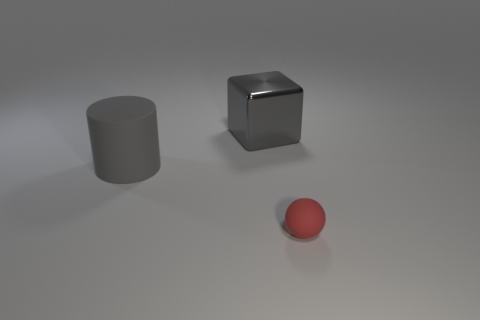What material is the big thing that is on the right side of the large object in front of the gray cube made of?
Offer a terse response. Metal. What shape is the gray thing left of the thing that is behind the matte thing behind the tiny sphere?
Your response must be concise. Cylinder. What number of cylinders are there?
Make the answer very short. 1. What is the shape of the big gray object in front of the big gray block?
Your response must be concise. Cylinder. There is a matte thing behind the matte thing to the right of the matte thing that is behind the tiny sphere; what is its color?
Provide a succinct answer. Gray. What shape is the other big object that is the same material as the red thing?
Make the answer very short. Cylinder. Are there fewer big red matte cylinders than big gray metal objects?
Provide a succinct answer. Yes. Do the small red ball and the big gray cube have the same material?
Ensure brevity in your answer.  No. What number of other objects are the same color as the ball?
Your answer should be very brief. 0. Is the number of tiny red rubber objects greater than the number of big cyan matte objects?
Offer a very short reply. Yes. 